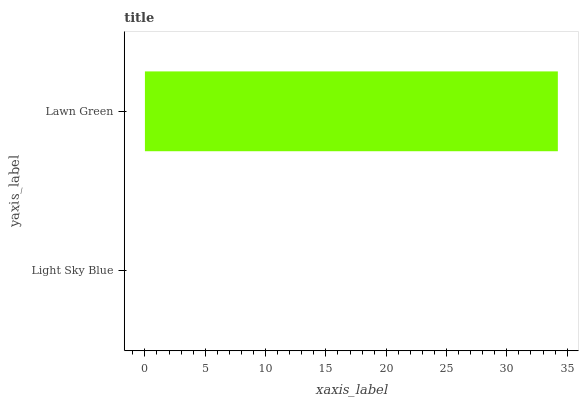Is Light Sky Blue the minimum?
Answer yes or no. Yes. Is Lawn Green the maximum?
Answer yes or no. Yes. Is Lawn Green the minimum?
Answer yes or no. No. Is Lawn Green greater than Light Sky Blue?
Answer yes or no. Yes. Is Light Sky Blue less than Lawn Green?
Answer yes or no. Yes. Is Light Sky Blue greater than Lawn Green?
Answer yes or no. No. Is Lawn Green less than Light Sky Blue?
Answer yes or no. No. Is Lawn Green the high median?
Answer yes or no. Yes. Is Light Sky Blue the low median?
Answer yes or no. Yes. Is Light Sky Blue the high median?
Answer yes or no. No. Is Lawn Green the low median?
Answer yes or no. No. 